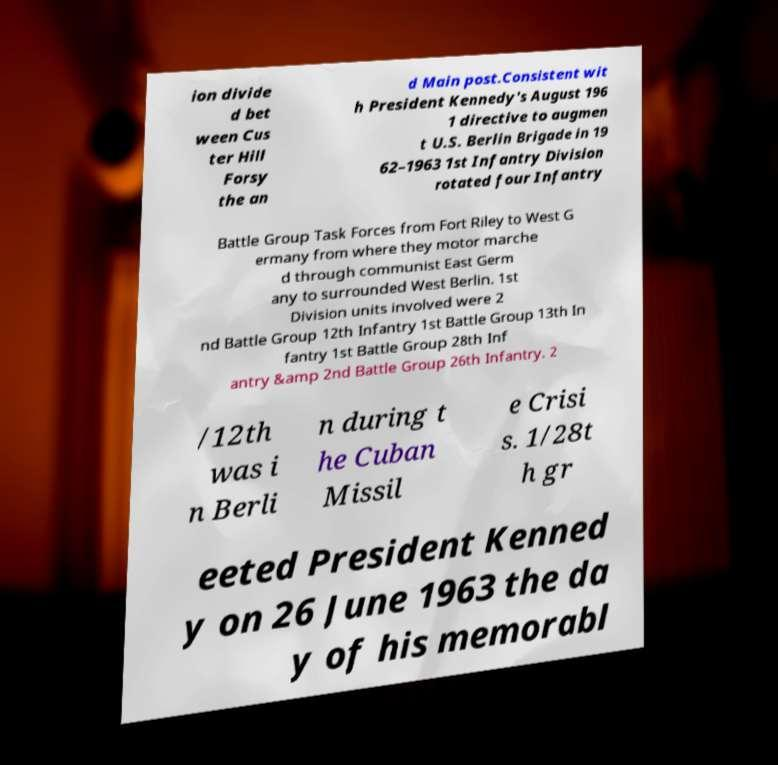Can you read and provide the text displayed in the image?This photo seems to have some interesting text. Can you extract and type it out for me? ion divide d bet ween Cus ter Hill Forsy the an d Main post.Consistent wit h President Kennedy's August 196 1 directive to augmen t U.S. Berlin Brigade in 19 62–1963 1st Infantry Division rotated four Infantry Battle Group Task Forces from Fort Riley to West G ermany from where they motor marche d through communist East Germ any to surrounded West Berlin. 1st Division units involved were 2 nd Battle Group 12th Infantry 1st Battle Group 13th In fantry 1st Battle Group 28th Inf antry &amp 2nd Battle Group 26th Infantry. 2 /12th was i n Berli n during t he Cuban Missil e Crisi s. 1/28t h gr eeted President Kenned y on 26 June 1963 the da y of his memorabl 